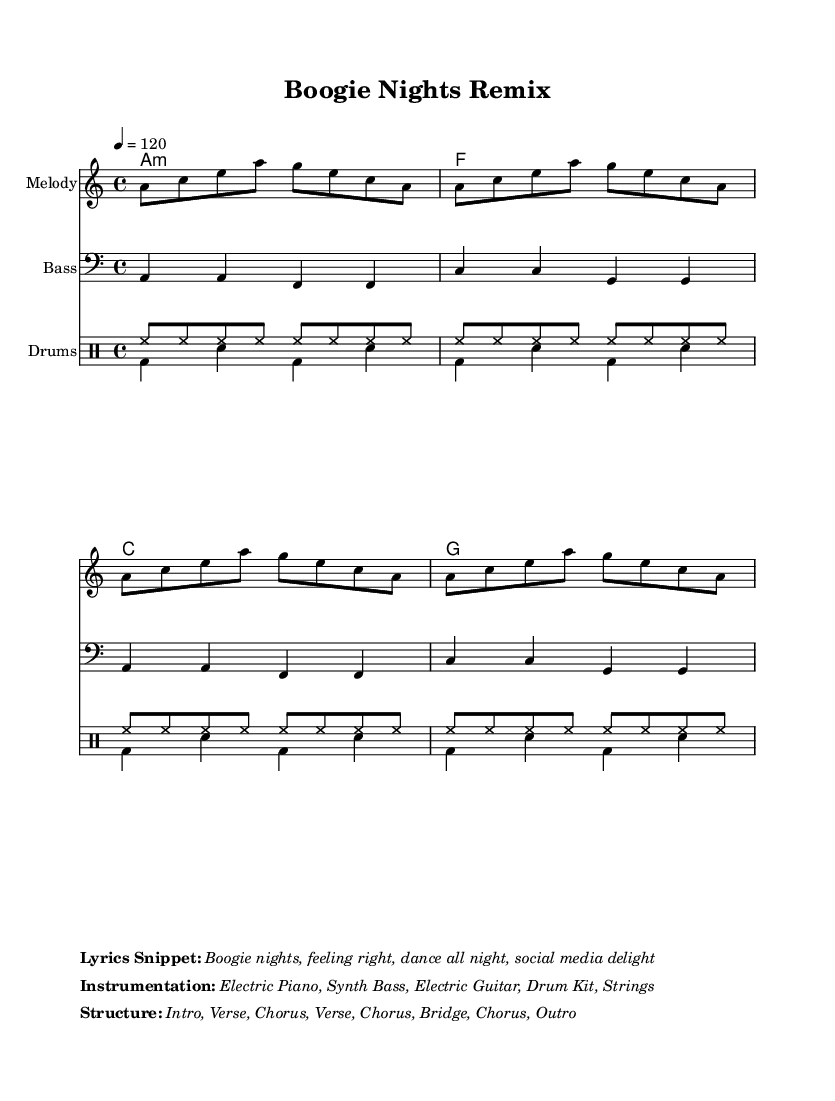What is the key signature of this music? The key signature is A minor, which has no sharps or flats (the relative major is C major). The key is indicated at the beginning of the score.
Answer: A minor What is the time signature of this music? The time signature is 4/4, meaning there are four beats in each measure and a quarter note gets one beat. It is shown at the beginning of the sheet music.
Answer: 4/4 What is the tempo of this music? The tempo is indicated as 120 beats per minute (bpm), which suggests a moderate pace, making it suitable for dancing. The tempo is specified in the score.
Answer: 120 How many sections does the structure have? The structure of the music includes an intro, two verses, three choruses, a bridge, and an outro. This totals to seven sections when counted.
Answer: Seven What instruments are featured in this piece? The instrumentation includes Electric Piano, Synth Bass, Electric Guitar, Drum Kit, and Strings, which are specified in the details around the score layout.
Answer: Electric Piano, Synth Bass, Electric Guitar, Drum Kit, Strings How many measures are in the melody? The melody consists of four repeated phrases of eight notes each, totaling 32 measures (as each phrase corresponds to two measures in a 4/4 time signature).
Answer: 32 